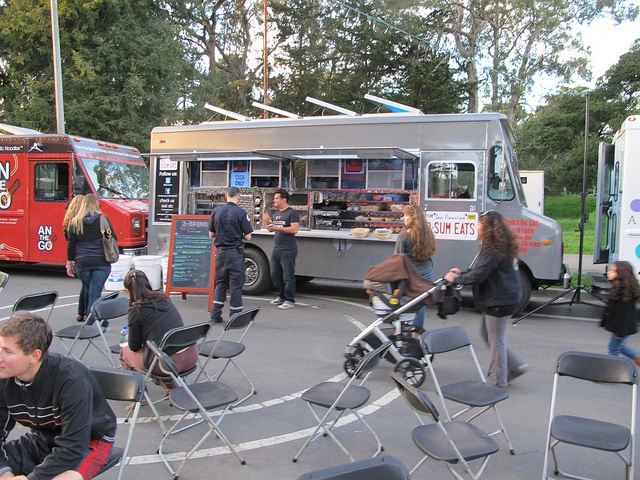Describe the objects in this image and their specific colors. I can see bus in violet, darkgray, gray, black, and lightgray tones, truck in violet, darkgray, gray, black, and lightgray tones, truck in violet, brown, gray, lightgray, and darkgray tones, people in violet, black, gray, and brown tones, and people in violet, black, and gray tones in this image. 